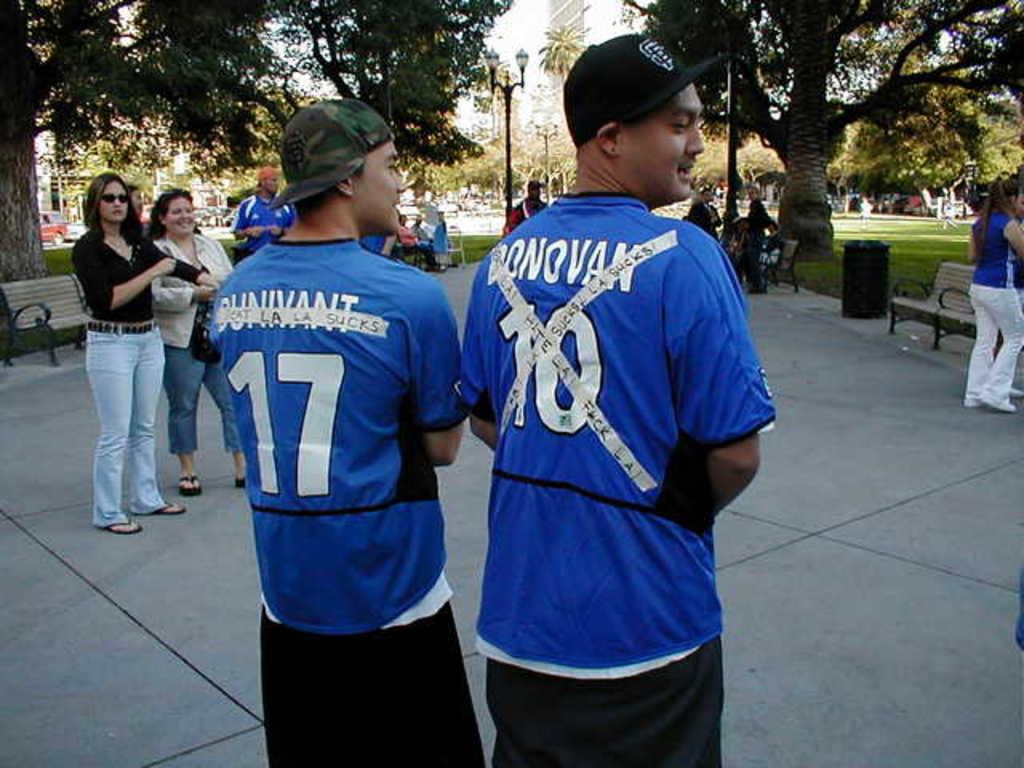What is the jersey number?
Give a very brief answer. 17. 